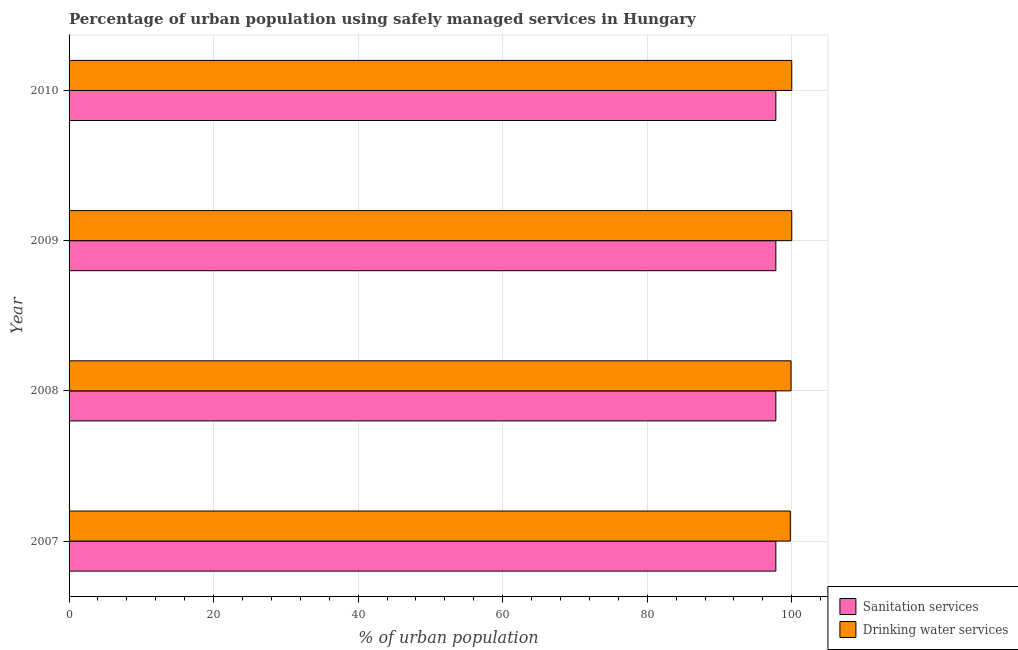How many different coloured bars are there?
Give a very brief answer. 2. What is the percentage of urban population who used sanitation services in 2008?
Provide a succinct answer. 97.8. Across all years, what is the maximum percentage of urban population who used sanitation services?
Offer a terse response. 97.8. Across all years, what is the minimum percentage of urban population who used drinking water services?
Give a very brief answer. 99.8. What is the total percentage of urban population who used sanitation services in the graph?
Provide a short and direct response. 391.2. What is the difference between the percentage of urban population who used sanitation services in 2007 and that in 2008?
Keep it short and to the point. 0. What is the difference between the percentage of urban population who used drinking water services in 2008 and the percentage of urban population who used sanitation services in 2007?
Ensure brevity in your answer.  2.1. What is the average percentage of urban population who used drinking water services per year?
Your response must be concise. 99.92. In how many years, is the percentage of urban population who used drinking water services greater than 32 %?
Your answer should be compact. 4. What is the ratio of the percentage of urban population who used sanitation services in 2007 to that in 2009?
Keep it short and to the point. 1. Is the percentage of urban population who used drinking water services in 2009 less than that in 2010?
Provide a succinct answer. No. Is the sum of the percentage of urban population who used drinking water services in 2008 and 2010 greater than the maximum percentage of urban population who used sanitation services across all years?
Your answer should be compact. Yes. What does the 2nd bar from the top in 2007 represents?
Keep it short and to the point. Sanitation services. What does the 1st bar from the bottom in 2009 represents?
Ensure brevity in your answer.  Sanitation services. How many bars are there?
Offer a very short reply. 8. Are all the bars in the graph horizontal?
Your response must be concise. Yes. What is the difference between two consecutive major ticks on the X-axis?
Offer a very short reply. 20. How many legend labels are there?
Make the answer very short. 2. How are the legend labels stacked?
Provide a short and direct response. Vertical. What is the title of the graph?
Your answer should be compact. Percentage of urban population using safely managed services in Hungary. Does "Domestic liabilities" appear as one of the legend labels in the graph?
Give a very brief answer. No. What is the label or title of the X-axis?
Your response must be concise. % of urban population. What is the % of urban population in Sanitation services in 2007?
Provide a short and direct response. 97.8. What is the % of urban population of Drinking water services in 2007?
Ensure brevity in your answer.  99.8. What is the % of urban population of Sanitation services in 2008?
Your response must be concise. 97.8. What is the % of urban population in Drinking water services in 2008?
Make the answer very short. 99.9. What is the % of urban population of Sanitation services in 2009?
Give a very brief answer. 97.8. What is the % of urban population of Drinking water services in 2009?
Offer a very short reply. 100. What is the % of urban population of Sanitation services in 2010?
Make the answer very short. 97.8. Across all years, what is the maximum % of urban population in Sanitation services?
Your answer should be compact. 97.8. Across all years, what is the maximum % of urban population in Drinking water services?
Your answer should be compact. 100. Across all years, what is the minimum % of urban population in Sanitation services?
Provide a succinct answer. 97.8. Across all years, what is the minimum % of urban population of Drinking water services?
Offer a terse response. 99.8. What is the total % of urban population of Sanitation services in the graph?
Make the answer very short. 391.2. What is the total % of urban population in Drinking water services in the graph?
Your response must be concise. 399.7. What is the difference between the % of urban population in Sanitation services in 2007 and that in 2008?
Ensure brevity in your answer.  0. What is the difference between the % of urban population in Drinking water services in 2007 and that in 2008?
Your response must be concise. -0.1. What is the difference between the % of urban population of Sanitation services in 2007 and that in 2010?
Offer a very short reply. 0. What is the difference between the % of urban population in Sanitation services in 2008 and that in 2010?
Make the answer very short. 0. What is the difference between the % of urban population of Drinking water services in 2009 and that in 2010?
Your answer should be very brief. 0. What is the difference between the % of urban population in Sanitation services in 2007 and the % of urban population in Drinking water services in 2009?
Ensure brevity in your answer.  -2.2. What is the difference between the % of urban population of Sanitation services in 2008 and the % of urban population of Drinking water services in 2009?
Provide a succinct answer. -2.2. What is the difference between the % of urban population of Sanitation services in 2008 and the % of urban population of Drinking water services in 2010?
Give a very brief answer. -2.2. What is the average % of urban population of Sanitation services per year?
Your answer should be compact. 97.8. What is the average % of urban population of Drinking water services per year?
Provide a succinct answer. 99.92. What is the ratio of the % of urban population in Drinking water services in 2007 to that in 2008?
Make the answer very short. 1. What is the ratio of the % of urban population in Drinking water services in 2007 to that in 2009?
Keep it short and to the point. 1. What is the ratio of the % of urban population in Drinking water services in 2007 to that in 2010?
Your answer should be compact. 1. What is the ratio of the % of urban population in Drinking water services in 2008 to that in 2009?
Keep it short and to the point. 1. What is the ratio of the % of urban population of Sanitation services in 2008 to that in 2010?
Ensure brevity in your answer.  1. What is the ratio of the % of urban population in Sanitation services in 2009 to that in 2010?
Provide a succinct answer. 1. What is the difference between the highest and the second highest % of urban population in Sanitation services?
Your answer should be compact. 0. What is the difference between the highest and the second highest % of urban population of Drinking water services?
Ensure brevity in your answer.  0. 